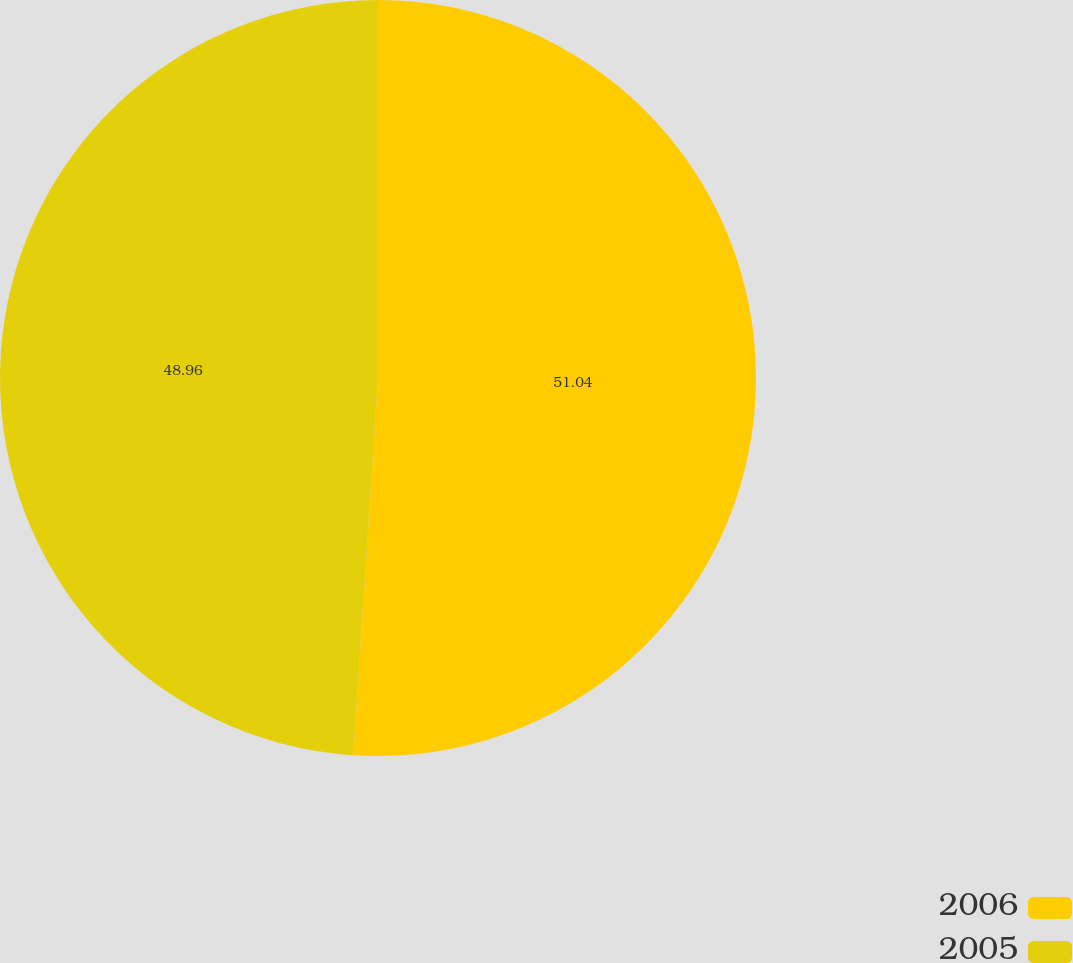Convert chart. <chart><loc_0><loc_0><loc_500><loc_500><pie_chart><fcel>2006<fcel>2005<nl><fcel>51.04%<fcel>48.96%<nl></chart> 